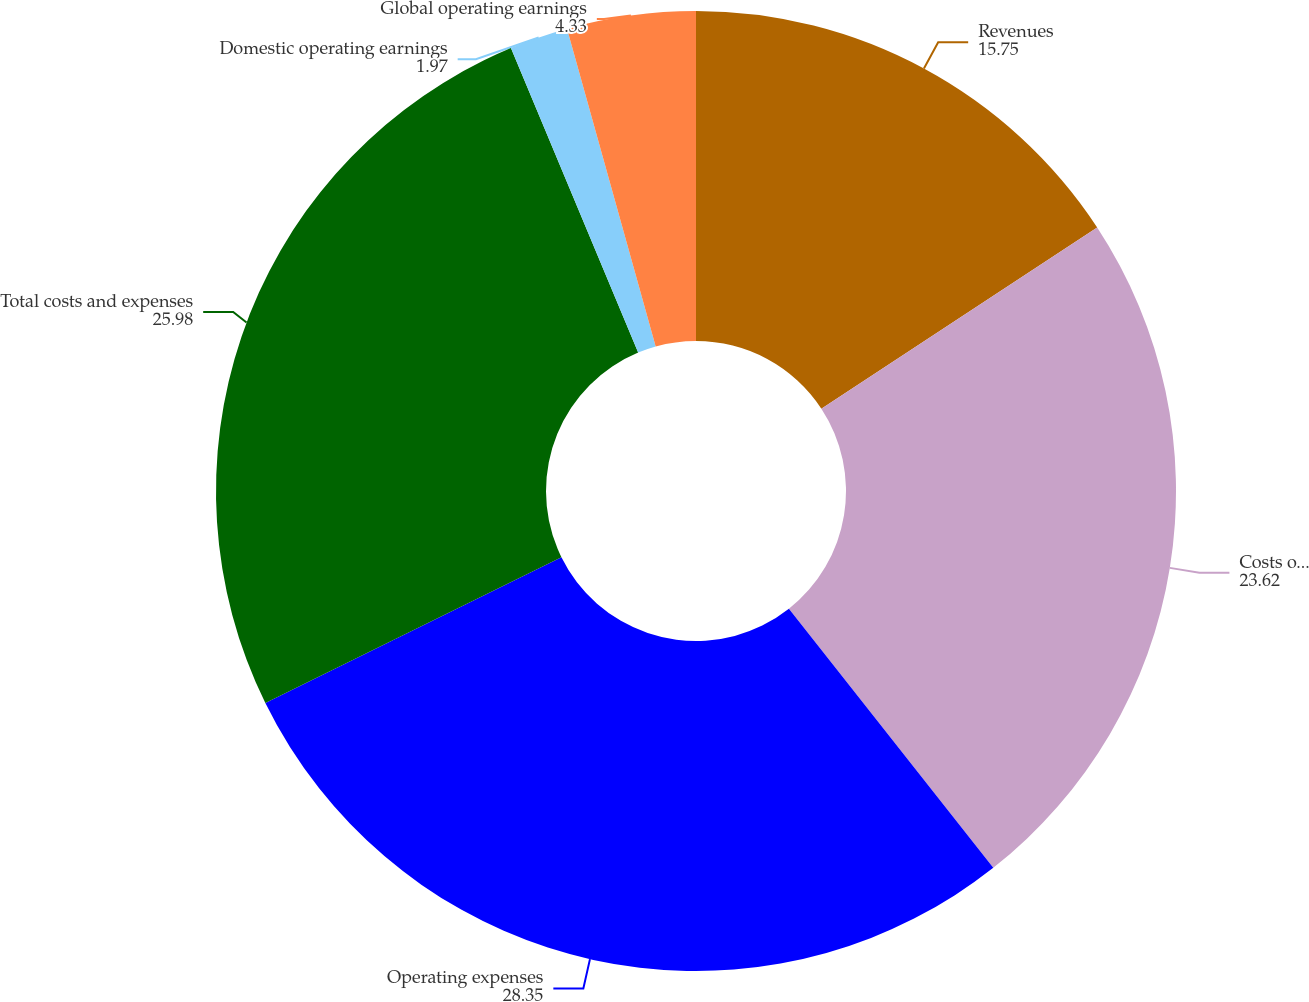<chart> <loc_0><loc_0><loc_500><loc_500><pie_chart><fcel>Revenues<fcel>Costs of revenue<fcel>Operating expenses<fcel>Total costs and expenses<fcel>Domestic operating earnings<fcel>Global operating earnings<nl><fcel>15.75%<fcel>23.62%<fcel>28.35%<fcel>25.98%<fcel>1.97%<fcel>4.33%<nl></chart> 